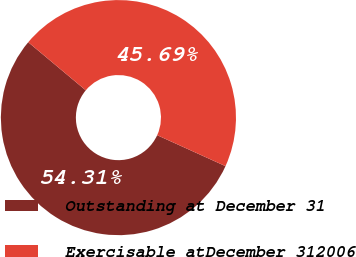<chart> <loc_0><loc_0><loc_500><loc_500><pie_chart><fcel>Outstanding at December 31<fcel>Exercisable atDecember 312006<nl><fcel>54.31%<fcel>45.69%<nl></chart> 